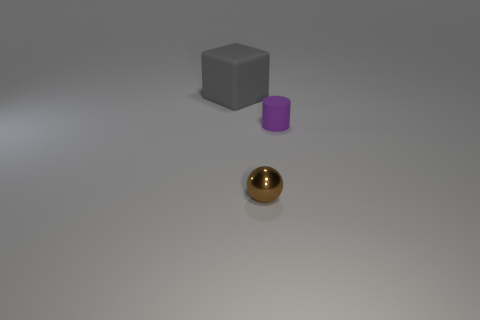Add 3 gray rubber blocks. How many objects exist? 6 Subtract all cylinders. How many objects are left? 2 Add 1 green metallic things. How many green metallic things exist? 1 Subtract 0 yellow cubes. How many objects are left? 3 Subtract all gray objects. Subtract all gray objects. How many objects are left? 1 Add 3 large cubes. How many large cubes are left? 4 